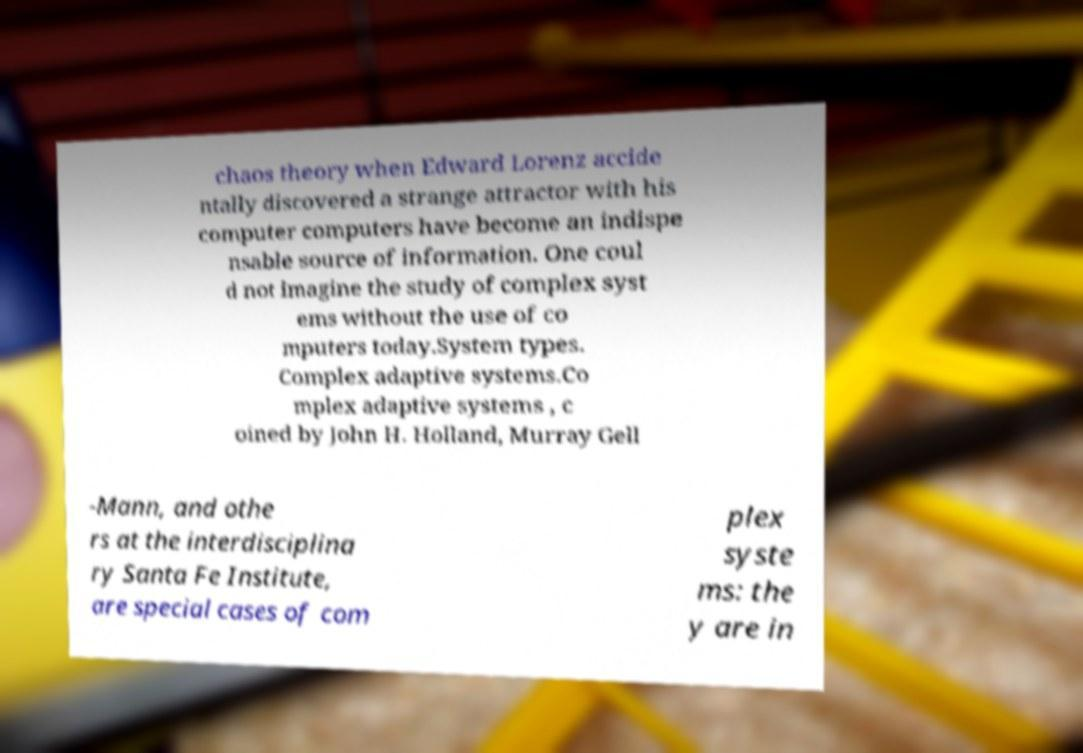Can you read and provide the text displayed in the image?This photo seems to have some interesting text. Can you extract and type it out for me? chaos theory when Edward Lorenz accide ntally discovered a strange attractor with his computer computers have become an indispe nsable source of information. One coul d not imagine the study of complex syst ems without the use of co mputers today.System types. Complex adaptive systems.Co mplex adaptive systems , c oined by John H. Holland, Murray Gell -Mann, and othe rs at the interdisciplina ry Santa Fe Institute, are special cases of com plex syste ms: the y are in 